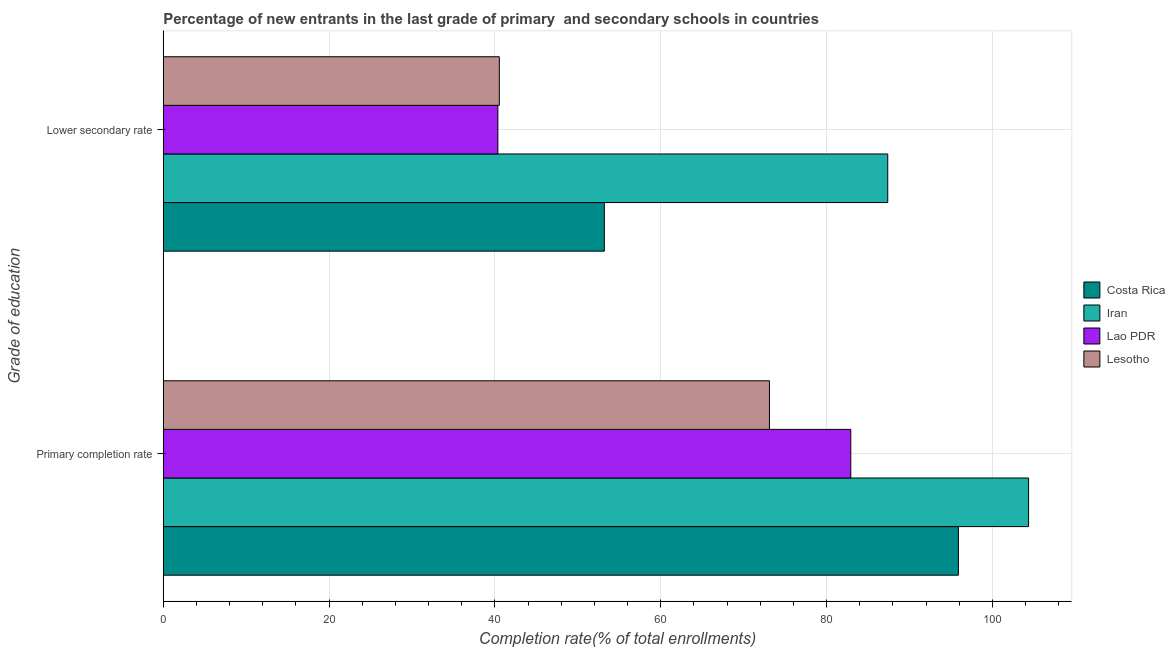How many different coloured bars are there?
Your response must be concise. 4. What is the label of the 1st group of bars from the top?
Keep it short and to the point. Lower secondary rate. What is the completion rate in primary schools in Iran?
Give a very brief answer. 104.37. Across all countries, what is the maximum completion rate in primary schools?
Offer a very short reply. 104.37. Across all countries, what is the minimum completion rate in primary schools?
Make the answer very short. 73.11. In which country was the completion rate in secondary schools maximum?
Provide a succinct answer. Iran. In which country was the completion rate in primary schools minimum?
Make the answer very short. Lesotho. What is the total completion rate in secondary schools in the graph?
Ensure brevity in your answer.  221.47. What is the difference between the completion rate in primary schools in Iran and that in Lesotho?
Provide a short and direct response. 31.25. What is the difference between the completion rate in secondary schools in Iran and the completion rate in primary schools in Costa Rica?
Your response must be concise. -8.52. What is the average completion rate in primary schools per country?
Offer a very short reply. 89.08. What is the difference between the completion rate in primary schools and completion rate in secondary schools in Iran?
Offer a terse response. 16.99. What is the ratio of the completion rate in secondary schools in Iran to that in Costa Rica?
Your response must be concise. 1.64. Is the completion rate in secondary schools in Iran less than that in Lao PDR?
Ensure brevity in your answer.  No. What does the 4th bar from the bottom in Lower secondary rate represents?
Provide a short and direct response. Lesotho. What is the difference between two consecutive major ticks on the X-axis?
Your answer should be compact. 20. Where does the legend appear in the graph?
Provide a succinct answer. Center right. How many legend labels are there?
Your response must be concise. 4. What is the title of the graph?
Give a very brief answer. Percentage of new entrants in the last grade of primary  and secondary schools in countries. What is the label or title of the X-axis?
Your response must be concise. Completion rate(% of total enrollments). What is the label or title of the Y-axis?
Your response must be concise. Grade of education. What is the Completion rate(% of total enrollments) of Costa Rica in Primary completion rate?
Provide a short and direct response. 95.9. What is the Completion rate(% of total enrollments) of Iran in Primary completion rate?
Give a very brief answer. 104.37. What is the Completion rate(% of total enrollments) in Lao PDR in Primary completion rate?
Give a very brief answer. 82.92. What is the Completion rate(% of total enrollments) of Lesotho in Primary completion rate?
Your answer should be very brief. 73.11. What is the Completion rate(% of total enrollments) in Costa Rica in Lower secondary rate?
Offer a very short reply. 53.2. What is the Completion rate(% of total enrollments) in Iran in Lower secondary rate?
Make the answer very short. 87.38. What is the Completion rate(% of total enrollments) of Lao PDR in Lower secondary rate?
Make the answer very short. 40.36. What is the Completion rate(% of total enrollments) of Lesotho in Lower secondary rate?
Make the answer very short. 40.53. Across all Grade of education, what is the maximum Completion rate(% of total enrollments) of Costa Rica?
Provide a succinct answer. 95.9. Across all Grade of education, what is the maximum Completion rate(% of total enrollments) of Iran?
Offer a very short reply. 104.37. Across all Grade of education, what is the maximum Completion rate(% of total enrollments) of Lao PDR?
Provide a succinct answer. 82.92. Across all Grade of education, what is the maximum Completion rate(% of total enrollments) in Lesotho?
Offer a terse response. 73.11. Across all Grade of education, what is the minimum Completion rate(% of total enrollments) of Costa Rica?
Offer a terse response. 53.2. Across all Grade of education, what is the minimum Completion rate(% of total enrollments) in Iran?
Your answer should be compact. 87.38. Across all Grade of education, what is the minimum Completion rate(% of total enrollments) in Lao PDR?
Offer a terse response. 40.36. Across all Grade of education, what is the minimum Completion rate(% of total enrollments) in Lesotho?
Make the answer very short. 40.53. What is the total Completion rate(% of total enrollments) of Costa Rica in the graph?
Give a very brief answer. 149.1. What is the total Completion rate(% of total enrollments) of Iran in the graph?
Offer a very short reply. 191.75. What is the total Completion rate(% of total enrollments) in Lao PDR in the graph?
Give a very brief answer. 123.28. What is the total Completion rate(% of total enrollments) of Lesotho in the graph?
Give a very brief answer. 113.65. What is the difference between the Completion rate(% of total enrollments) of Costa Rica in Primary completion rate and that in Lower secondary rate?
Offer a very short reply. 42.7. What is the difference between the Completion rate(% of total enrollments) of Iran in Primary completion rate and that in Lower secondary rate?
Offer a terse response. 16.99. What is the difference between the Completion rate(% of total enrollments) in Lao PDR in Primary completion rate and that in Lower secondary rate?
Offer a terse response. 42.57. What is the difference between the Completion rate(% of total enrollments) in Lesotho in Primary completion rate and that in Lower secondary rate?
Give a very brief answer. 32.58. What is the difference between the Completion rate(% of total enrollments) in Costa Rica in Primary completion rate and the Completion rate(% of total enrollments) in Iran in Lower secondary rate?
Give a very brief answer. 8.52. What is the difference between the Completion rate(% of total enrollments) in Costa Rica in Primary completion rate and the Completion rate(% of total enrollments) in Lao PDR in Lower secondary rate?
Make the answer very short. 55.55. What is the difference between the Completion rate(% of total enrollments) in Costa Rica in Primary completion rate and the Completion rate(% of total enrollments) in Lesotho in Lower secondary rate?
Offer a very short reply. 55.37. What is the difference between the Completion rate(% of total enrollments) of Iran in Primary completion rate and the Completion rate(% of total enrollments) of Lao PDR in Lower secondary rate?
Ensure brevity in your answer.  64.01. What is the difference between the Completion rate(% of total enrollments) in Iran in Primary completion rate and the Completion rate(% of total enrollments) in Lesotho in Lower secondary rate?
Your response must be concise. 63.84. What is the difference between the Completion rate(% of total enrollments) of Lao PDR in Primary completion rate and the Completion rate(% of total enrollments) of Lesotho in Lower secondary rate?
Ensure brevity in your answer.  42.39. What is the average Completion rate(% of total enrollments) in Costa Rica per Grade of education?
Offer a terse response. 74.55. What is the average Completion rate(% of total enrollments) in Iran per Grade of education?
Keep it short and to the point. 95.87. What is the average Completion rate(% of total enrollments) of Lao PDR per Grade of education?
Offer a terse response. 61.64. What is the average Completion rate(% of total enrollments) of Lesotho per Grade of education?
Offer a very short reply. 56.82. What is the difference between the Completion rate(% of total enrollments) of Costa Rica and Completion rate(% of total enrollments) of Iran in Primary completion rate?
Your answer should be compact. -8.47. What is the difference between the Completion rate(% of total enrollments) in Costa Rica and Completion rate(% of total enrollments) in Lao PDR in Primary completion rate?
Keep it short and to the point. 12.98. What is the difference between the Completion rate(% of total enrollments) of Costa Rica and Completion rate(% of total enrollments) of Lesotho in Primary completion rate?
Your answer should be very brief. 22.79. What is the difference between the Completion rate(% of total enrollments) in Iran and Completion rate(% of total enrollments) in Lao PDR in Primary completion rate?
Your answer should be very brief. 21.44. What is the difference between the Completion rate(% of total enrollments) of Iran and Completion rate(% of total enrollments) of Lesotho in Primary completion rate?
Make the answer very short. 31.25. What is the difference between the Completion rate(% of total enrollments) of Lao PDR and Completion rate(% of total enrollments) of Lesotho in Primary completion rate?
Keep it short and to the point. 9.81. What is the difference between the Completion rate(% of total enrollments) in Costa Rica and Completion rate(% of total enrollments) in Iran in Lower secondary rate?
Your answer should be compact. -34.18. What is the difference between the Completion rate(% of total enrollments) in Costa Rica and Completion rate(% of total enrollments) in Lao PDR in Lower secondary rate?
Offer a very short reply. 12.84. What is the difference between the Completion rate(% of total enrollments) in Costa Rica and Completion rate(% of total enrollments) in Lesotho in Lower secondary rate?
Offer a very short reply. 12.66. What is the difference between the Completion rate(% of total enrollments) of Iran and Completion rate(% of total enrollments) of Lao PDR in Lower secondary rate?
Your answer should be very brief. 47.03. What is the difference between the Completion rate(% of total enrollments) of Iran and Completion rate(% of total enrollments) of Lesotho in Lower secondary rate?
Offer a very short reply. 46.85. What is the difference between the Completion rate(% of total enrollments) of Lao PDR and Completion rate(% of total enrollments) of Lesotho in Lower secondary rate?
Offer a very short reply. -0.18. What is the ratio of the Completion rate(% of total enrollments) of Costa Rica in Primary completion rate to that in Lower secondary rate?
Your answer should be compact. 1.8. What is the ratio of the Completion rate(% of total enrollments) in Iran in Primary completion rate to that in Lower secondary rate?
Offer a terse response. 1.19. What is the ratio of the Completion rate(% of total enrollments) of Lao PDR in Primary completion rate to that in Lower secondary rate?
Your response must be concise. 2.05. What is the ratio of the Completion rate(% of total enrollments) of Lesotho in Primary completion rate to that in Lower secondary rate?
Keep it short and to the point. 1.8. What is the difference between the highest and the second highest Completion rate(% of total enrollments) of Costa Rica?
Your answer should be very brief. 42.7. What is the difference between the highest and the second highest Completion rate(% of total enrollments) of Iran?
Keep it short and to the point. 16.99. What is the difference between the highest and the second highest Completion rate(% of total enrollments) of Lao PDR?
Provide a short and direct response. 42.57. What is the difference between the highest and the second highest Completion rate(% of total enrollments) of Lesotho?
Ensure brevity in your answer.  32.58. What is the difference between the highest and the lowest Completion rate(% of total enrollments) of Costa Rica?
Your response must be concise. 42.7. What is the difference between the highest and the lowest Completion rate(% of total enrollments) of Iran?
Ensure brevity in your answer.  16.99. What is the difference between the highest and the lowest Completion rate(% of total enrollments) in Lao PDR?
Make the answer very short. 42.57. What is the difference between the highest and the lowest Completion rate(% of total enrollments) of Lesotho?
Your answer should be compact. 32.58. 